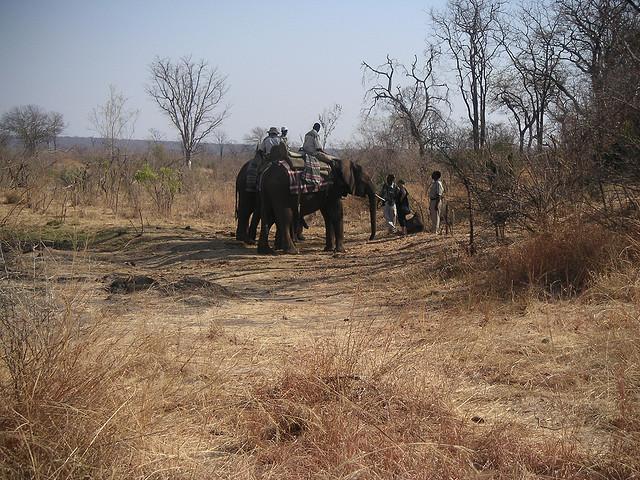How many people can fit on this elephant?
Give a very brief answer. 2. How many elephant are there?
Give a very brief answer. 2. How many elephants are there?
Give a very brief answer. 2. How many people are riding the elephant?
Give a very brief answer. 3. How many elephants are in the photo?
Give a very brief answer. 2. How many elephants can you see?
Give a very brief answer. 2. 